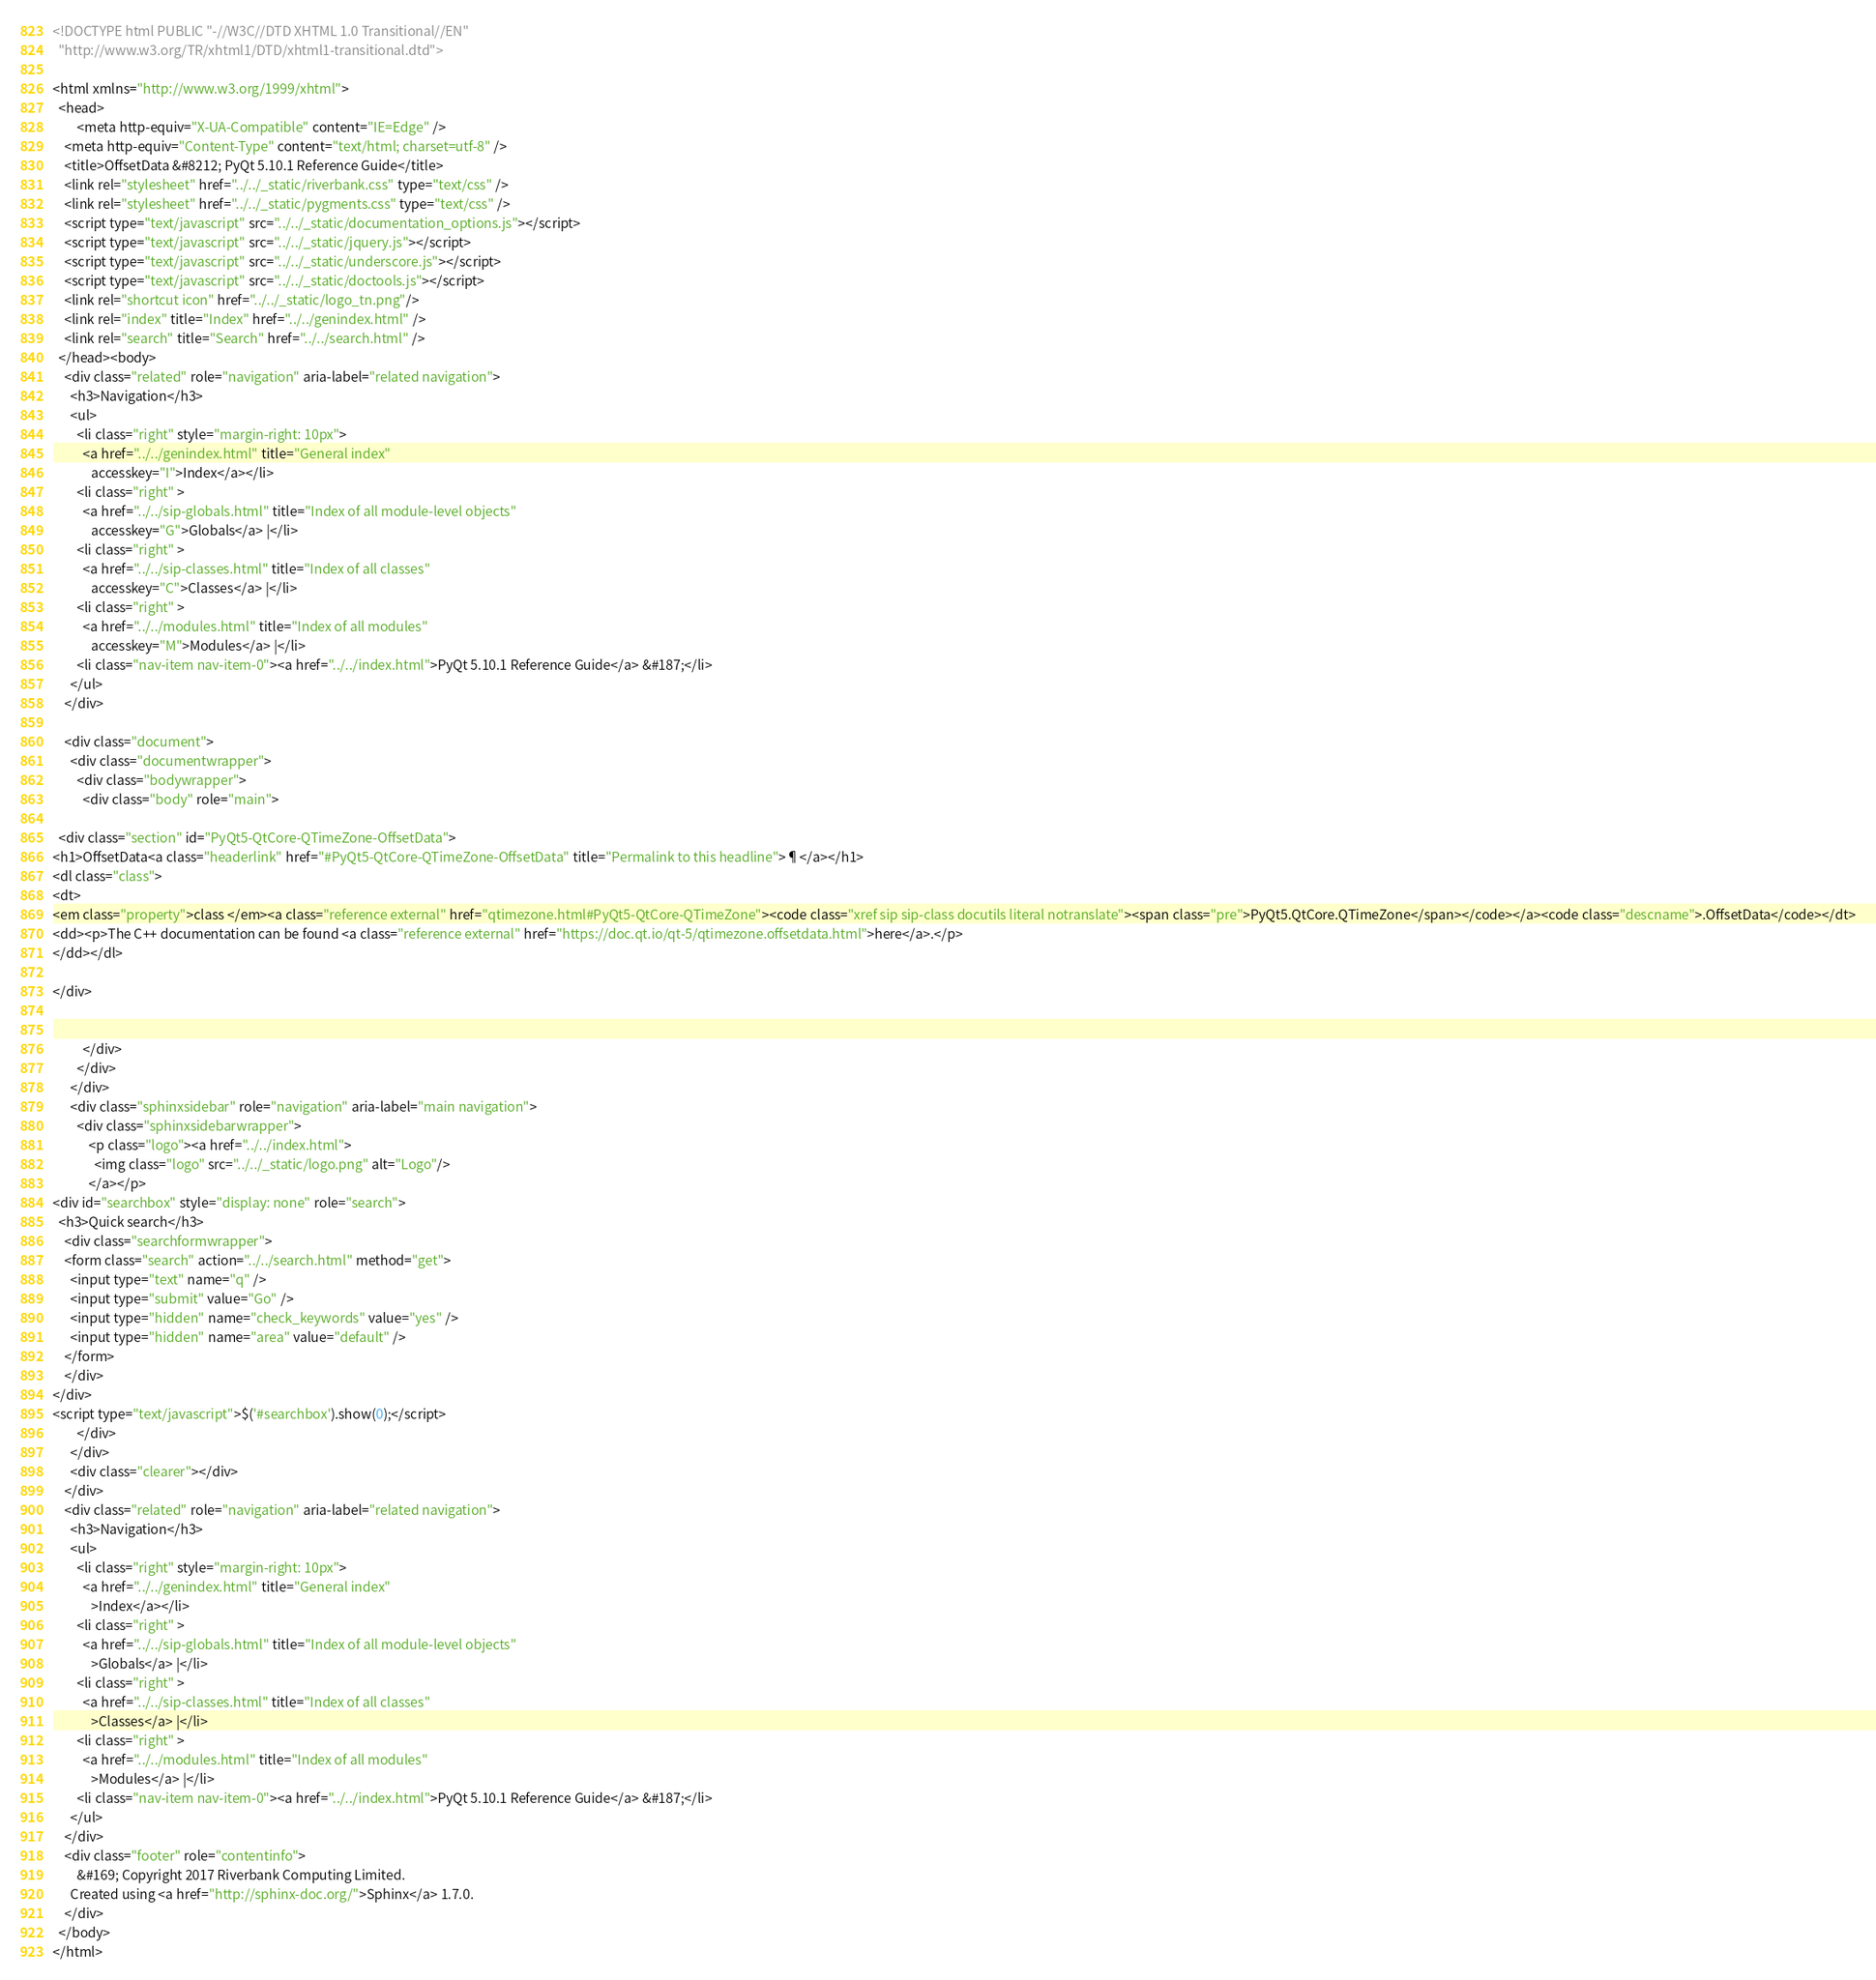Convert code to text. <code><loc_0><loc_0><loc_500><loc_500><_HTML_>
<!DOCTYPE html PUBLIC "-//W3C//DTD XHTML 1.0 Transitional//EN"
  "http://www.w3.org/TR/xhtml1/DTD/xhtml1-transitional.dtd">

<html xmlns="http://www.w3.org/1999/xhtml">
  <head>
        <meta http-equiv="X-UA-Compatible" content="IE=Edge" />
    <meta http-equiv="Content-Type" content="text/html; charset=utf-8" />
    <title>OffsetData &#8212; PyQt 5.10.1 Reference Guide</title>
    <link rel="stylesheet" href="../../_static/riverbank.css" type="text/css" />
    <link rel="stylesheet" href="../../_static/pygments.css" type="text/css" />
    <script type="text/javascript" src="../../_static/documentation_options.js"></script>
    <script type="text/javascript" src="../../_static/jquery.js"></script>
    <script type="text/javascript" src="../../_static/underscore.js"></script>
    <script type="text/javascript" src="../../_static/doctools.js"></script>
    <link rel="shortcut icon" href="../../_static/logo_tn.png"/>
    <link rel="index" title="Index" href="../../genindex.html" />
    <link rel="search" title="Search" href="../../search.html" /> 
  </head><body>
    <div class="related" role="navigation" aria-label="related navigation">
      <h3>Navigation</h3>
      <ul>
        <li class="right" style="margin-right: 10px">
          <a href="../../genindex.html" title="General index"
             accesskey="I">Index</a></li>
        <li class="right" >
          <a href="../../sip-globals.html" title="Index of all module-level objects"
             accesskey="G">Globals</a> |</li>
        <li class="right" >
          <a href="../../sip-classes.html" title="Index of all classes"
             accesskey="C">Classes</a> |</li>
        <li class="right" >
          <a href="../../modules.html" title="Index of all modules"
             accesskey="M">Modules</a> |</li>
        <li class="nav-item nav-item-0"><a href="../../index.html">PyQt 5.10.1 Reference Guide</a> &#187;</li> 
      </ul>
    </div>  

    <div class="document">
      <div class="documentwrapper">
        <div class="bodywrapper">
          <div class="body" role="main">
            
  <div class="section" id="PyQt5-QtCore-QTimeZone-OffsetData">
<h1>OffsetData<a class="headerlink" href="#PyQt5-QtCore-QTimeZone-OffsetData" title="Permalink to this headline">¶</a></h1>
<dl class="class">
<dt>
<em class="property">class </em><a class="reference external" href="qtimezone.html#PyQt5-QtCore-QTimeZone"><code class="xref sip sip-class docutils literal notranslate"><span class="pre">PyQt5.QtCore.QTimeZone</span></code></a><code class="descname">.OffsetData</code></dt>
<dd><p>The C++ documentation can be found <a class="reference external" href="https://doc.qt.io/qt-5/qtimezone.offsetdata.html">here</a>.</p>
</dd></dl>

</div>


          </div>
        </div>
      </div>
      <div class="sphinxsidebar" role="navigation" aria-label="main navigation">
        <div class="sphinxsidebarwrapper">
            <p class="logo"><a href="../../index.html">
              <img class="logo" src="../../_static/logo.png" alt="Logo"/>
            </a></p>
<div id="searchbox" style="display: none" role="search">
  <h3>Quick search</h3>
    <div class="searchformwrapper">
    <form class="search" action="../../search.html" method="get">
      <input type="text" name="q" />
      <input type="submit" value="Go" />
      <input type="hidden" name="check_keywords" value="yes" />
      <input type="hidden" name="area" value="default" />
    </form>
    </div>
</div>
<script type="text/javascript">$('#searchbox').show(0);</script>
        </div>
      </div>
      <div class="clearer"></div>
    </div>
    <div class="related" role="navigation" aria-label="related navigation">
      <h3>Navigation</h3>
      <ul>
        <li class="right" style="margin-right: 10px">
          <a href="../../genindex.html" title="General index"
             >Index</a></li>
        <li class="right" >
          <a href="../../sip-globals.html" title="Index of all module-level objects"
             >Globals</a> |</li>
        <li class="right" >
          <a href="../../sip-classes.html" title="Index of all classes"
             >Classes</a> |</li>
        <li class="right" >
          <a href="../../modules.html" title="Index of all modules"
             >Modules</a> |</li>
        <li class="nav-item nav-item-0"><a href="../../index.html">PyQt 5.10.1 Reference Guide</a> &#187;</li> 
      </ul>
    </div>
    <div class="footer" role="contentinfo">
        &#169; Copyright 2017 Riverbank Computing Limited.
      Created using <a href="http://sphinx-doc.org/">Sphinx</a> 1.7.0.
    </div>
  </body>
</html></code> 